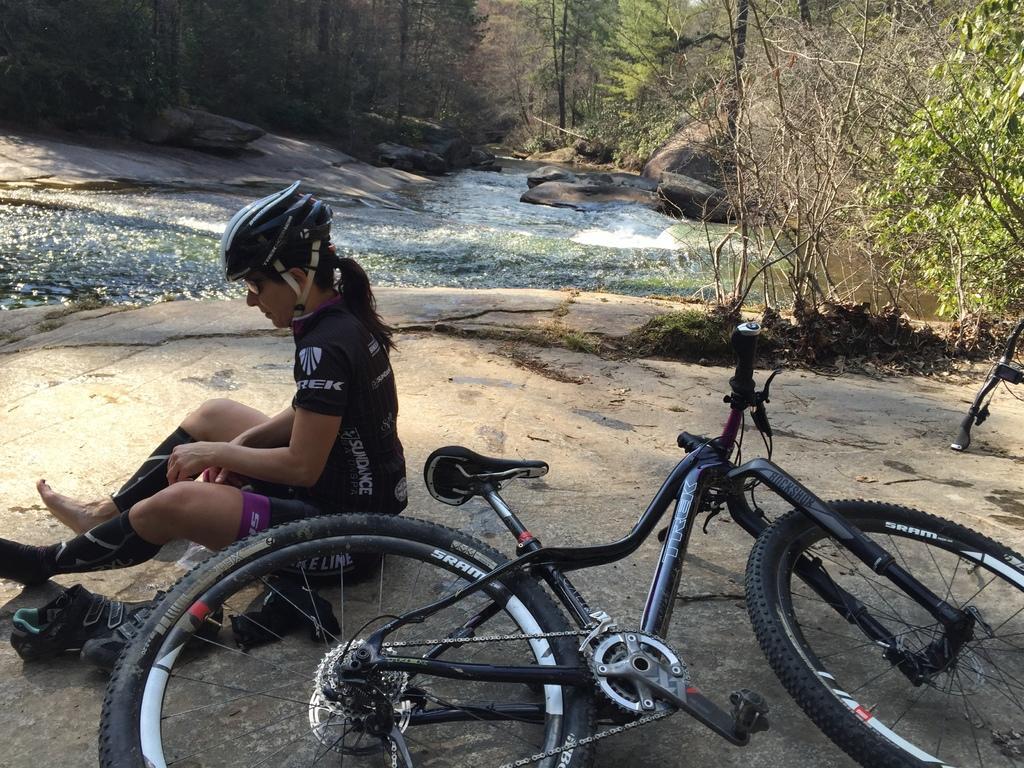Can you describe this image briefly? A beautiful woman is sitting, she wore a black color dress, helmet and here it is a cycle, which is in black color. In the middle water is flowing and there are trees. 